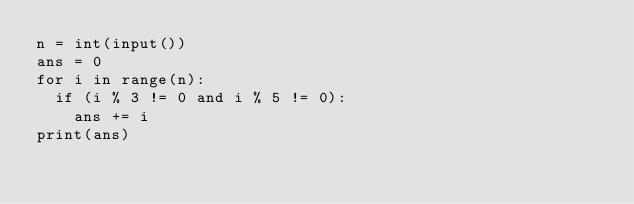<code> <loc_0><loc_0><loc_500><loc_500><_Python_>n = int(input())
ans = 0
for i in range(n):
  if (i % 3 != 0 and i % 5 != 0):
    ans += i
print(ans)</code> 